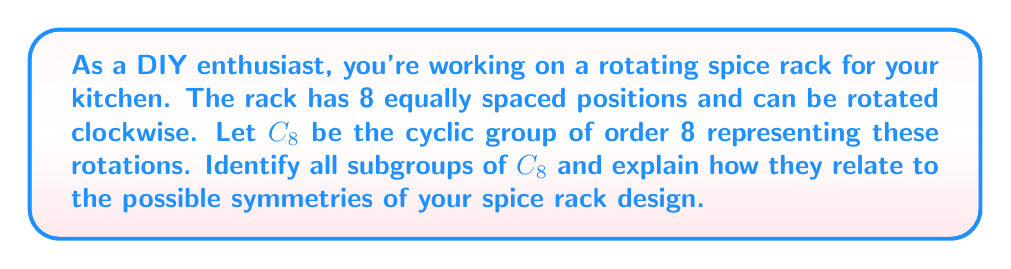Solve this math problem. Let's approach this step-by-step:

1) First, recall that $C_8 = \{e, r, r^2, r^3, r^4, r^5, r^6, r^7\}$, where $e$ is the identity (no rotation) and $r$ represents a 45° clockwise rotation.

2) To find subgroups, we need to identify elements that, when combined, only produce elements within the same set. We'll start with the smallest and work our way up:

   a) $\{e\}$ is always a subgroup, representing no rotation.

   b) $\{e, r^4\}$ is a subgroup of order 2. $r^4$ represents a 180° rotation.

   c) $\{e, r^2, r^4, r^6\}$ is a subgroup of order 4. $r^2$ represents a 90° rotation.

   d) $\{e, r, r^2, r^3, r^4, r^5, r^6, r^7\}$ is the entire group $C_8$.

3) To verify these are all subgroups, we can use Lagrange's theorem, which states that the order of a subgroup must divide the order of the group. The possible orders are the divisors of 8: 1, 2, 4, and 8.

4) Relating to the spice rack:
   - $\{e\}$: The rack has no rotational symmetry.
   - $\{e, r^4\}$: The rack looks the same after a 180° rotation.
   - $\{e, r^2, r^4, r^6\}$: The rack looks the same after 90°, 180°, or 270° rotations.
   - $C_8$: The rack looks the same after any 45° rotation.

These subgroups represent different levels of symmetry you could incorporate into your spice rack design, from no symmetry to complete 45° rotational symmetry.
Answer: The subgroups of $C_8$ are:
1) $\{e\}$
2) $\{e, r^4\}$
3) $\{e, r^2, r^4, r^6\}$
4) $\{e, r, r^2, r^3, r^4, r^5, r^6, r^7\}$ (the entire group $C_8$) 